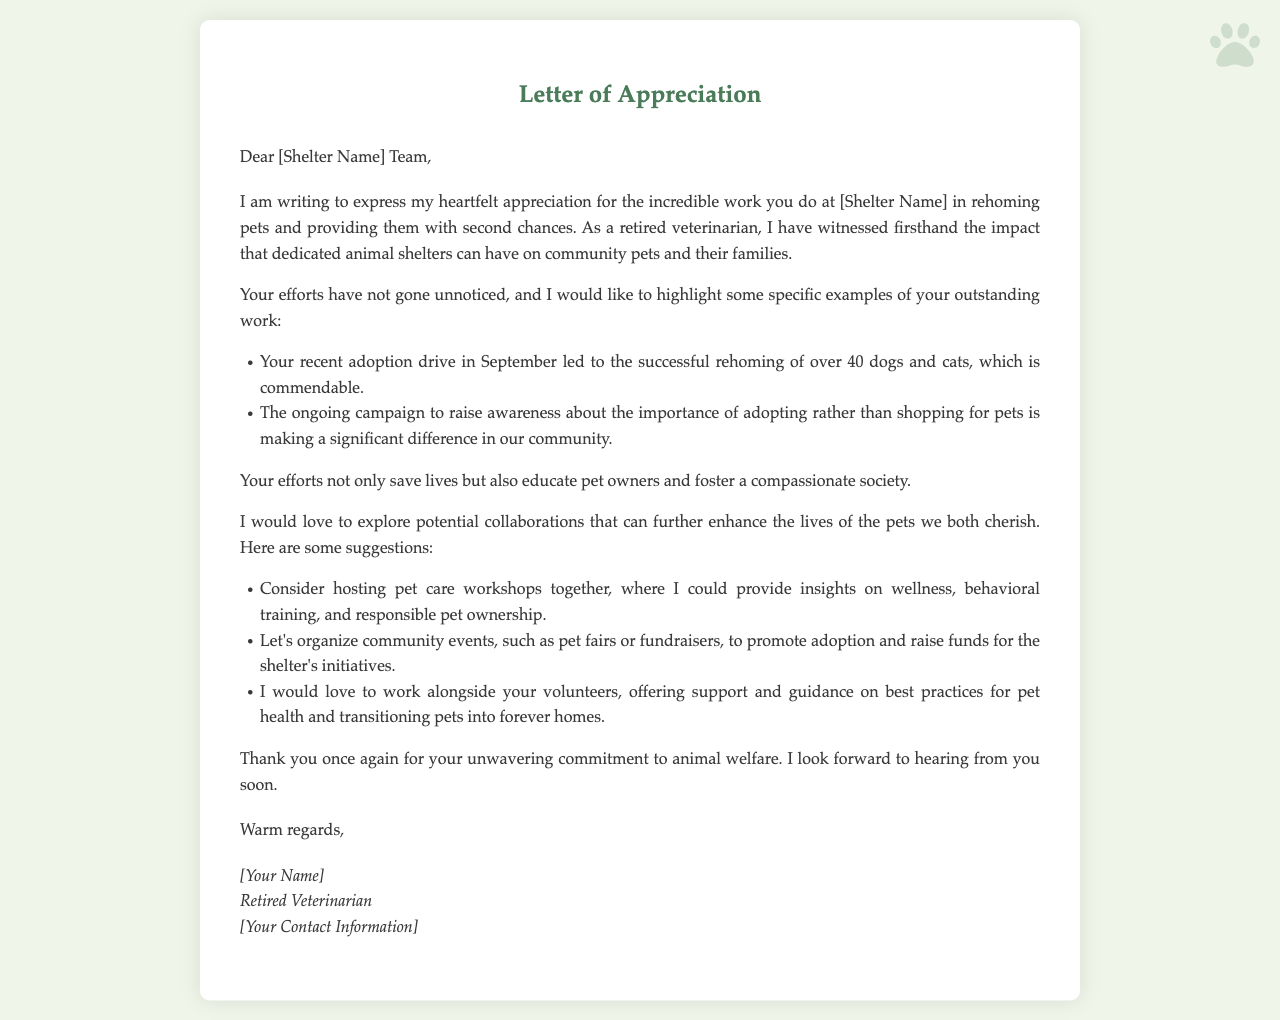What is the title of the letter? The title of the letter can be found at the top of the document, which is "Letter of Appreciation."
Answer: Letter of Appreciation Who is the author of the letter? The author is identified at the end of the letter as "[Your Name]," which is a placeholder for personal information.
Answer: [Your Name] What specific examples of the shelter's work are mentioned? The letter lists two specific examples regarding the shelter's work in rehoming pets and raising awareness about adoption.
Answer: Adoption drive and awareness campaign How many pets were rehomed in September? The document states the number of pets rehomed during an adoption drive in September.
Answer: 40 What type of workshops does the author suggest hosting? The author proposes hosting workshops focused on a particular theme relevant to pet care.
Answer: Pet care workshops What is one suggested event to promote adoption? The letter includes a suggestion to organize a specific type of community event to promote pet adoption.
Answer: Pet fairs What is the primary focus of the letter? The main theme of the letter revolves around gratitude and collaboration for animal welfare.
Answer: Appreciation and collaboration What is the closing remark of the letter? The closing remark summarizes the author's feelings toward the shelter and anticipation of a response.
Answer: Warm regards 